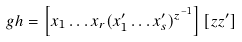<formula> <loc_0><loc_0><loc_500><loc_500>g h = \left [ x _ { 1 } \dots x _ { r } ( x _ { 1 } ^ { \prime } \dots x _ { s } ^ { \prime } ) ^ { z ^ { - 1 } } \right ] \left [ z z ^ { \prime } \right ]</formula> 